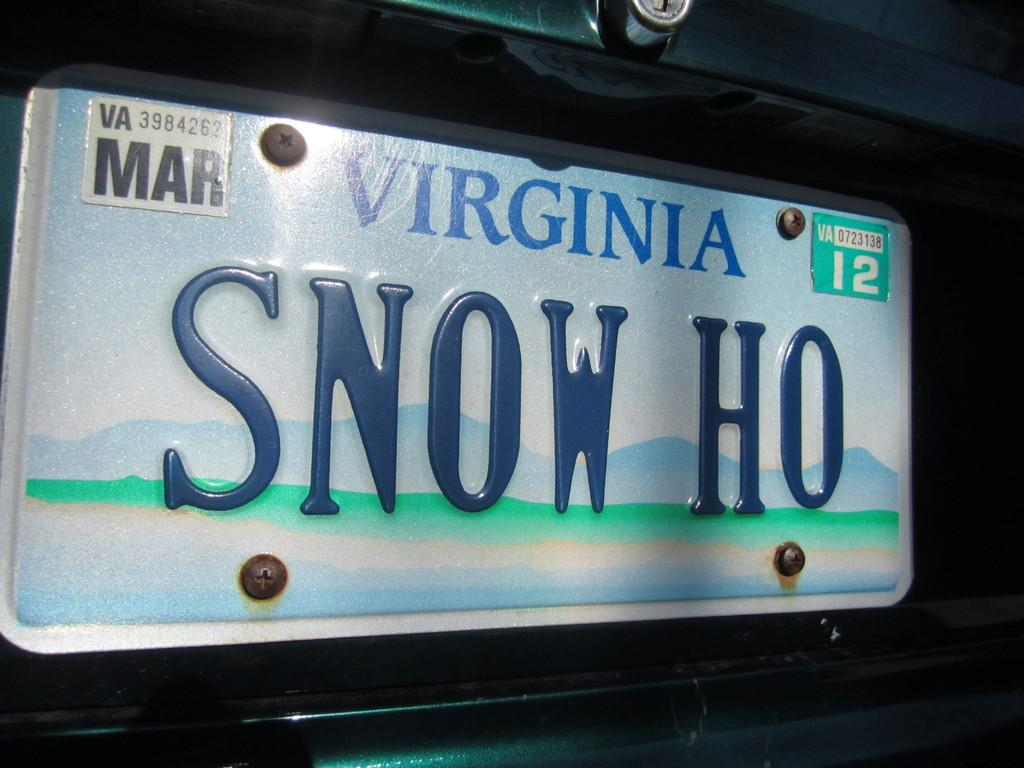What is the main object in the image? There is a board in the image. What is written or displayed on the board? The board contains text and numbers. How many shoes are visible on the board in the image? There are no shoes present on the board in the image. What type of jewel can be seen on the board in the image? There are no jewels present on the board in the image. 